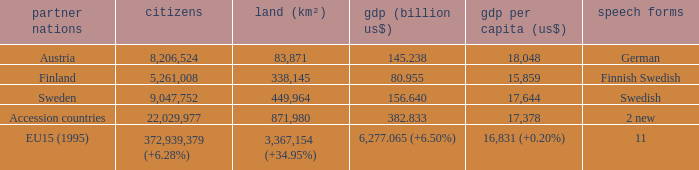Name the area for german 83871.0. 